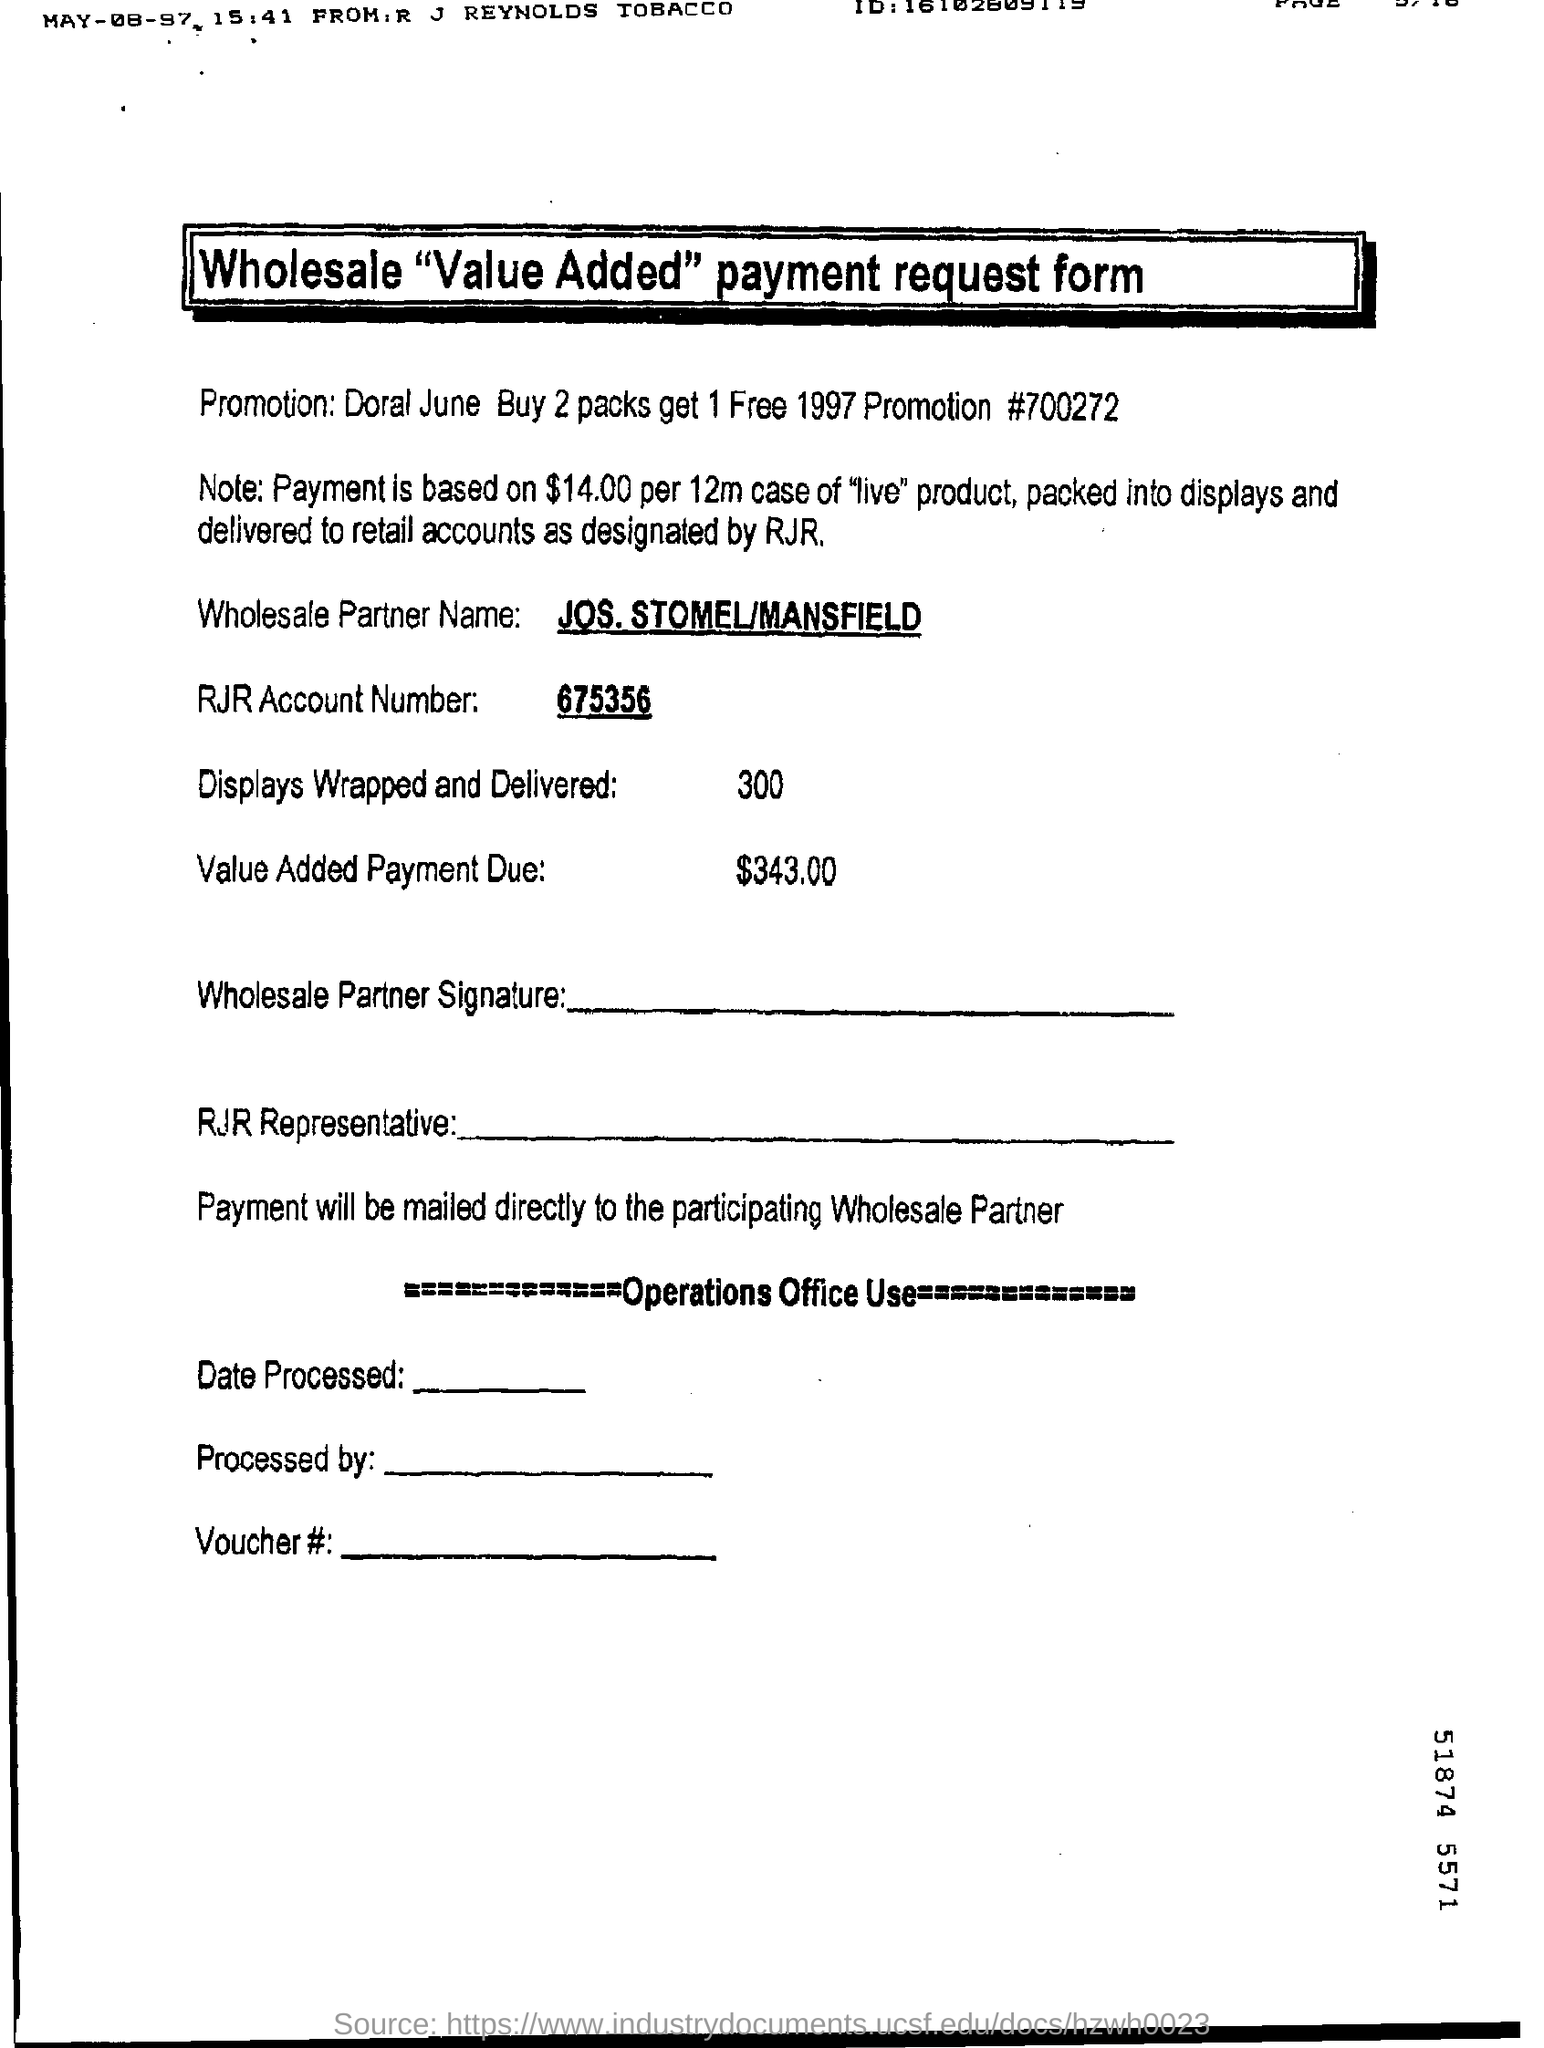What is the title of the form?
Your answer should be compact. Wholesale "value added" payment request form. What is the promotion?
Ensure brevity in your answer.  675356. What is the promotion number?
Make the answer very short. #700272. What is the name of Wholesale Partner?
Your response must be concise. Jos. stomel/mansfield. What is the RJR account number?
Your answer should be very brief. 675356. How many displays wrapped and delivered?
Make the answer very short. 300. How much is the value added payment due?
Ensure brevity in your answer.  343.00. 